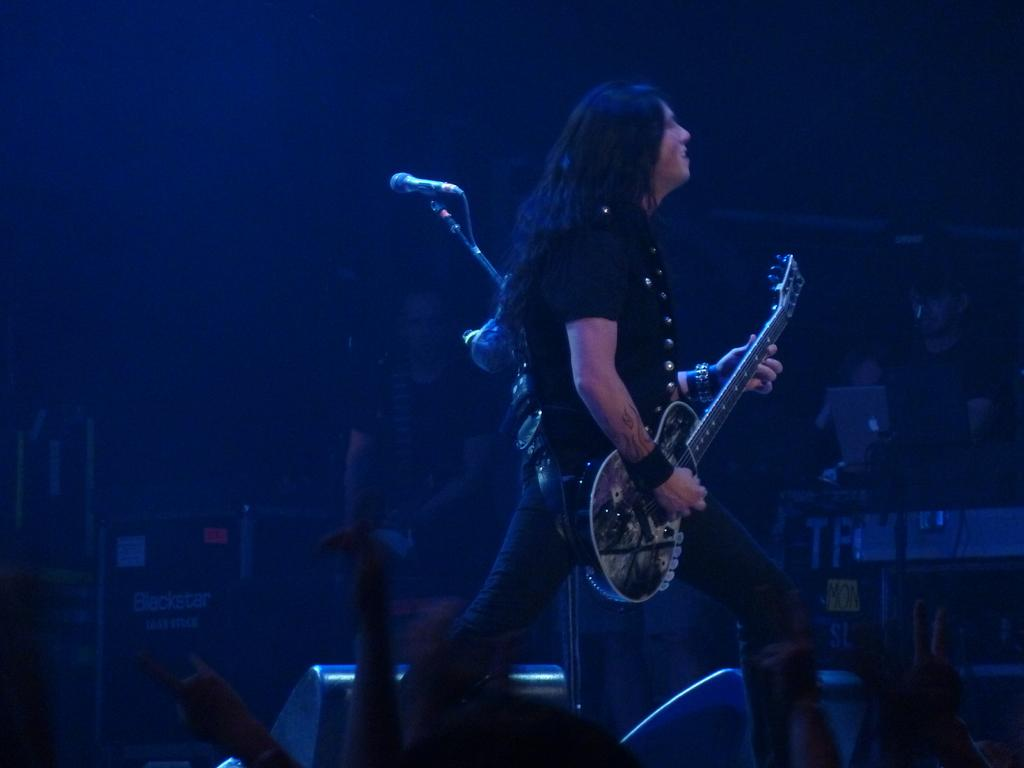Who is the main subject in the image? There is a man in the middle of the image. What is the man wearing? The man is wearing a t-shirt and trousers. What is the man doing in the image? The man is playing a guitar. Are there any other people in the image? Yes, there are people in the middle of the image. What other objects can be seen in the image? There is a microphone, speakers, and other musical instruments in the middle of the image. How many apples are on the guitar in the image? There are no apples present in the image, and the guitar is not associated with any fruit. 